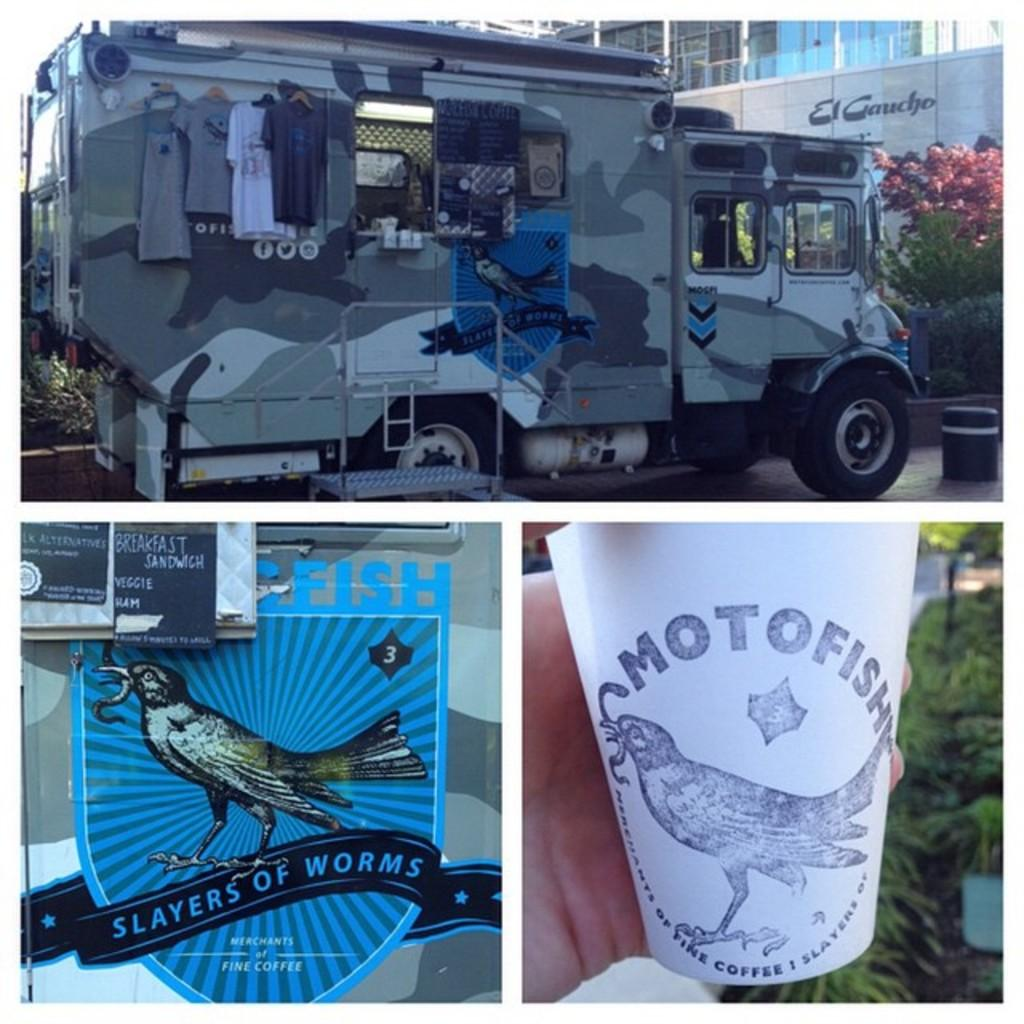<image>
Describe the image concisely. A military style truck with the brand Slayer of Worms written on the side of it. 